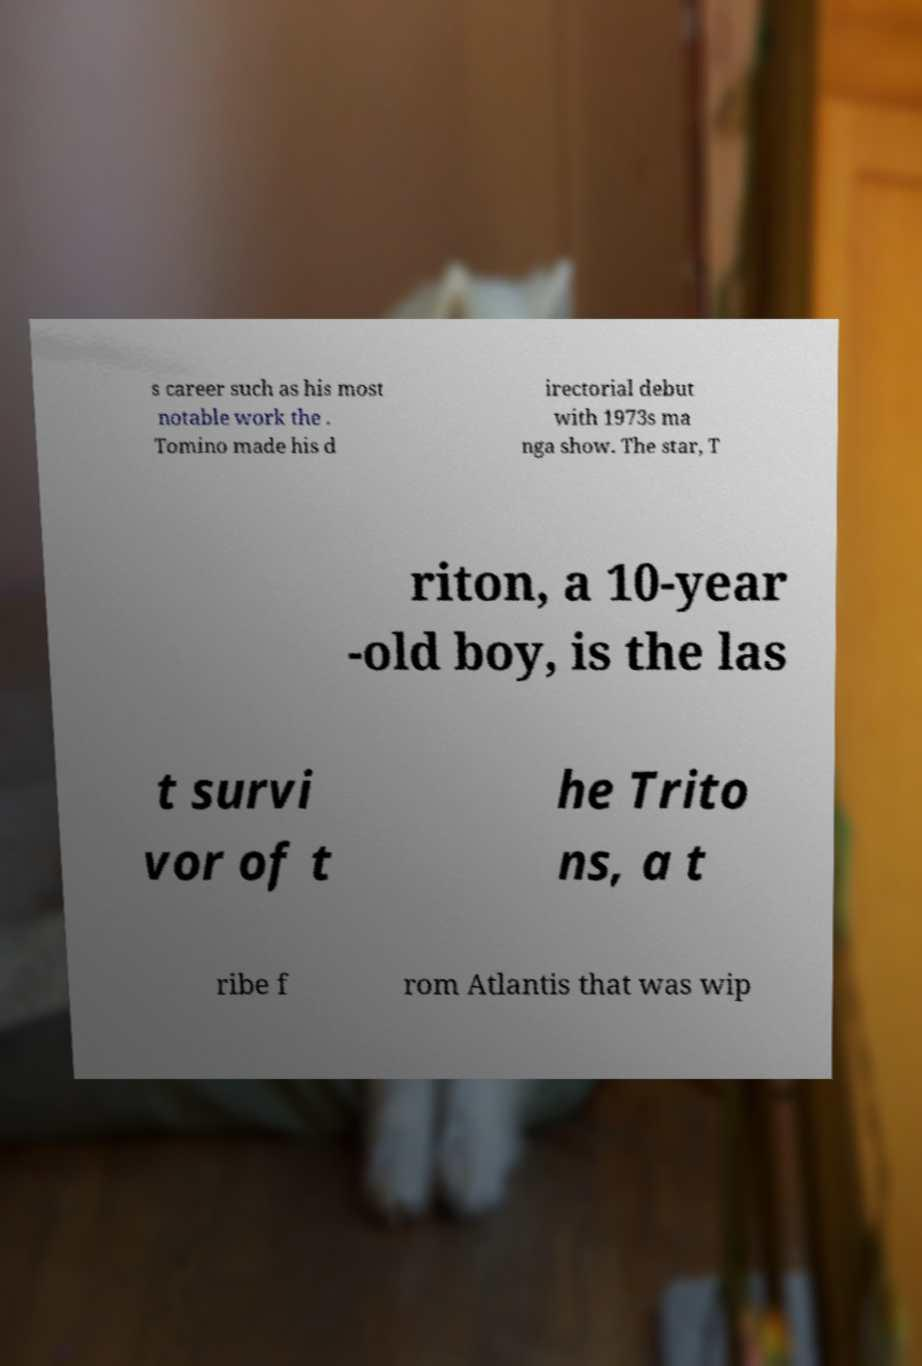Please read and relay the text visible in this image. What does it say? s career such as his most notable work the . Tomino made his d irectorial debut with 1973s ma nga show. The star, T riton, a 10-year -old boy, is the las t survi vor of t he Trito ns, a t ribe f rom Atlantis that was wip 